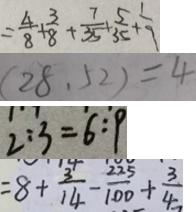<formula> <loc_0><loc_0><loc_500><loc_500>= \frac { 4 } { 8 } + \frac { 3 } { 8 } + \frac { 7 } { 3 5 } + \frac { 5 } { 3 5 } + \frac { 1 } { 9 } 
 ( 2 8 , 5 2 ) = 4 
 2 : 3 = 6 : 9 
 = 8 + \frac { 3 } { 1 4 } - \frac { 2 2 5 } { 1 0 0 } + \frac { 3 } { 4 }</formula> 